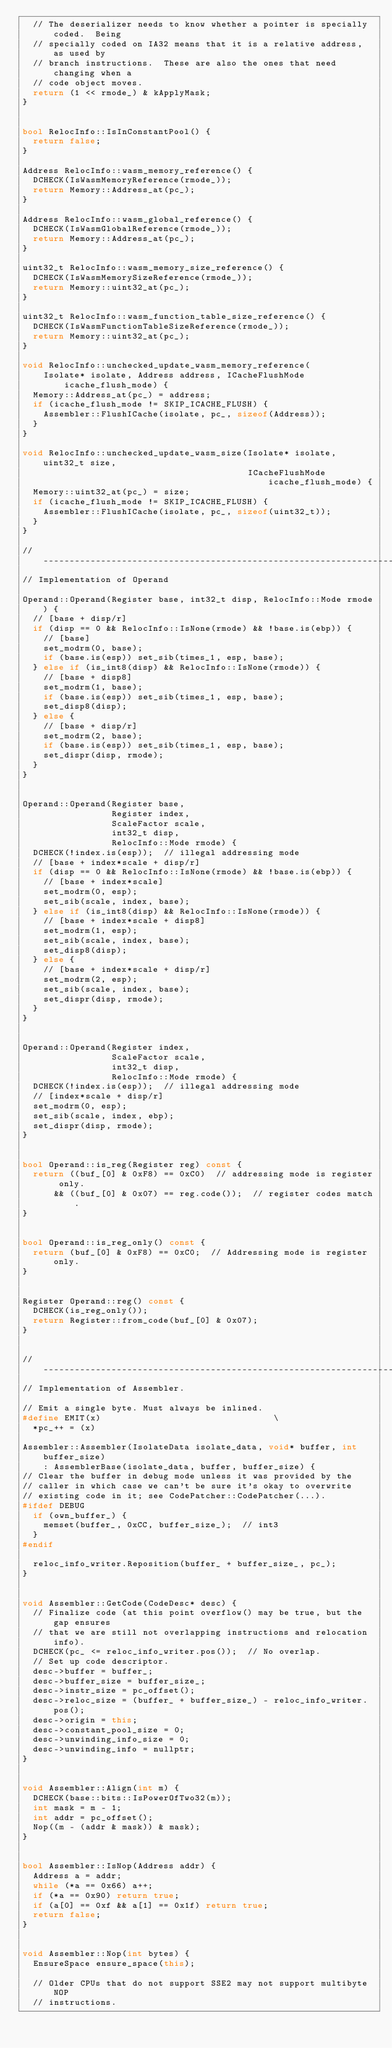Convert code to text. <code><loc_0><loc_0><loc_500><loc_500><_C++_>  // The deserializer needs to know whether a pointer is specially coded.  Being
  // specially coded on IA32 means that it is a relative address, as used by
  // branch instructions.  These are also the ones that need changing when a
  // code object moves.
  return (1 << rmode_) & kApplyMask;
}


bool RelocInfo::IsInConstantPool() {
  return false;
}

Address RelocInfo::wasm_memory_reference() {
  DCHECK(IsWasmMemoryReference(rmode_));
  return Memory::Address_at(pc_);
}

Address RelocInfo::wasm_global_reference() {
  DCHECK(IsWasmGlobalReference(rmode_));
  return Memory::Address_at(pc_);
}

uint32_t RelocInfo::wasm_memory_size_reference() {
  DCHECK(IsWasmMemorySizeReference(rmode_));
  return Memory::uint32_at(pc_);
}

uint32_t RelocInfo::wasm_function_table_size_reference() {
  DCHECK(IsWasmFunctionTableSizeReference(rmode_));
  return Memory::uint32_at(pc_);
}

void RelocInfo::unchecked_update_wasm_memory_reference(
    Isolate* isolate, Address address, ICacheFlushMode icache_flush_mode) {
  Memory::Address_at(pc_) = address;
  if (icache_flush_mode != SKIP_ICACHE_FLUSH) {
    Assembler::FlushICache(isolate, pc_, sizeof(Address));
  }
}

void RelocInfo::unchecked_update_wasm_size(Isolate* isolate, uint32_t size,
                                           ICacheFlushMode icache_flush_mode) {
  Memory::uint32_at(pc_) = size;
  if (icache_flush_mode != SKIP_ICACHE_FLUSH) {
    Assembler::FlushICache(isolate, pc_, sizeof(uint32_t));
  }
}

// -----------------------------------------------------------------------------
// Implementation of Operand

Operand::Operand(Register base, int32_t disp, RelocInfo::Mode rmode) {
  // [base + disp/r]
  if (disp == 0 && RelocInfo::IsNone(rmode) && !base.is(ebp)) {
    // [base]
    set_modrm(0, base);
    if (base.is(esp)) set_sib(times_1, esp, base);
  } else if (is_int8(disp) && RelocInfo::IsNone(rmode)) {
    // [base + disp8]
    set_modrm(1, base);
    if (base.is(esp)) set_sib(times_1, esp, base);
    set_disp8(disp);
  } else {
    // [base + disp/r]
    set_modrm(2, base);
    if (base.is(esp)) set_sib(times_1, esp, base);
    set_dispr(disp, rmode);
  }
}


Operand::Operand(Register base,
                 Register index,
                 ScaleFactor scale,
                 int32_t disp,
                 RelocInfo::Mode rmode) {
  DCHECK(!index.is(esp));  // illegal addressing mode
  // [base + index*scale + disp/r]
  if (disp == 0 && RelocInfo::IsNone(rmode) && !base.is(ebp)) {
    // [base + index*scale]
    set_modrm(0, esp);
    set_sib(scale, index, base);
  } else if (is_int8(disp) && RelocInfo::IsNone(rmode)) {
    // [base + index*scale + disp8]
    set_modrm(1, esp);
    set_sib(scale, index, base);
    set_disp8(disp);
  } else {
    // [base + index*scale + disp/r]
    set_modrm(2, esp);
    set_sib(scale, index, base);
    set_dispr(disp, rmode);
  }
}


Operand::Operand(Register index,
                 ScaleFactor scale,
                 int32_t disp,
                 RelocInfo::Mode rmode) {
  DCHECK(!index.is(esp));  // illegal addressing mode
  // [index*scale + disp/r]
  set_modrm(0, esp);
  set_sib(scale, index, ebp);
  set_dispr(disp, rmode);
}


bool Operand::is_reg(Register reg) const {
  return ((buf_[0] & 0xF8) == 0xC0)  // addressing mode is register only.
      && ((buf_[0] & 0x07) == reg.code());  // register codes match.
}


bool Operand::is_reg_only() const {
  return (buf_[0] & 0xF8) == 0xC0;  // Addressing mode is register only.
}


Register Operand::reg() const {
  DCHECK(is_reg_only());
  return Register::from_code(buf_[0] & 0x07);
}


// -----------------------------------------------------------------------------
// Implementation of Assembler.

// Emit a single byte. Must always be inlined.
#define EMIT(x)                                 \
  *pc_++ = (x)

Assembler::Assembler(IsolateData isolate_data, void* buffer, int buffer_size)
    : AssemblerBase(isolate_data, buffer, buffer_size) {
// Clear the buffer in debug mode unless it was provided by the
// caller in which case we can't be sure it's okay to overwrite
// existing code in it; see CodePatcher::CodePatcher(...).
#ifdef DEBUG
  if (own_buffer_) {
    memset(buffer_, 0xCC, buffer_size_);  // int3
  }
#endif

  reloc_info_writer.Reposition(buffer_ + buffer_size_, pc_);
}


void Assembler::GetCode(CodeDesc* desc) {
  // Finalize code (at this point overflow() may be true, but the gap ensures
  // that we are still not overlapping instructions and relocation info).
  DCHECK(pc_ <= reloc_info_writer.pos());  // No overlap.
  // Set up code descriptor.
  desc->buffer = buffer_;
  desc->buffer_size = buffer_size_;
  desc->instr_size = pc_offset();
  desc->reloc_size = (buffer_ + buffer_size_) - reloc_info_writer.pos();
  desc->origin = this;
  desc->constant_pool_size = 0;
  desc->unwinding_info_size = 0;
  desc->unwinding_info = nullptr;
}


void Assembler::Align(int m) {
  DCHECK(base::bits::IsPowerOfTwo32(m));
  int mask = m - 1;
  int addr = pc_offset();
  Nop((m - (addr & mask)) & mask);
}


bool Assembler::IsNop(Address addr) {
  Address a = addr;
  while (*a == 0x66) a++;
  if (*a == 0x90) return true;
  if (a[0] == 0xf && a[1] == 0x1f) return true;
  return false;
}


void Assembler::Nop(int bytes) {
  EnsureSpace ensure_space(this);

  // Older CPUs that do not support SSE2 may not support multibyte NOP
  // instructions.</code> 